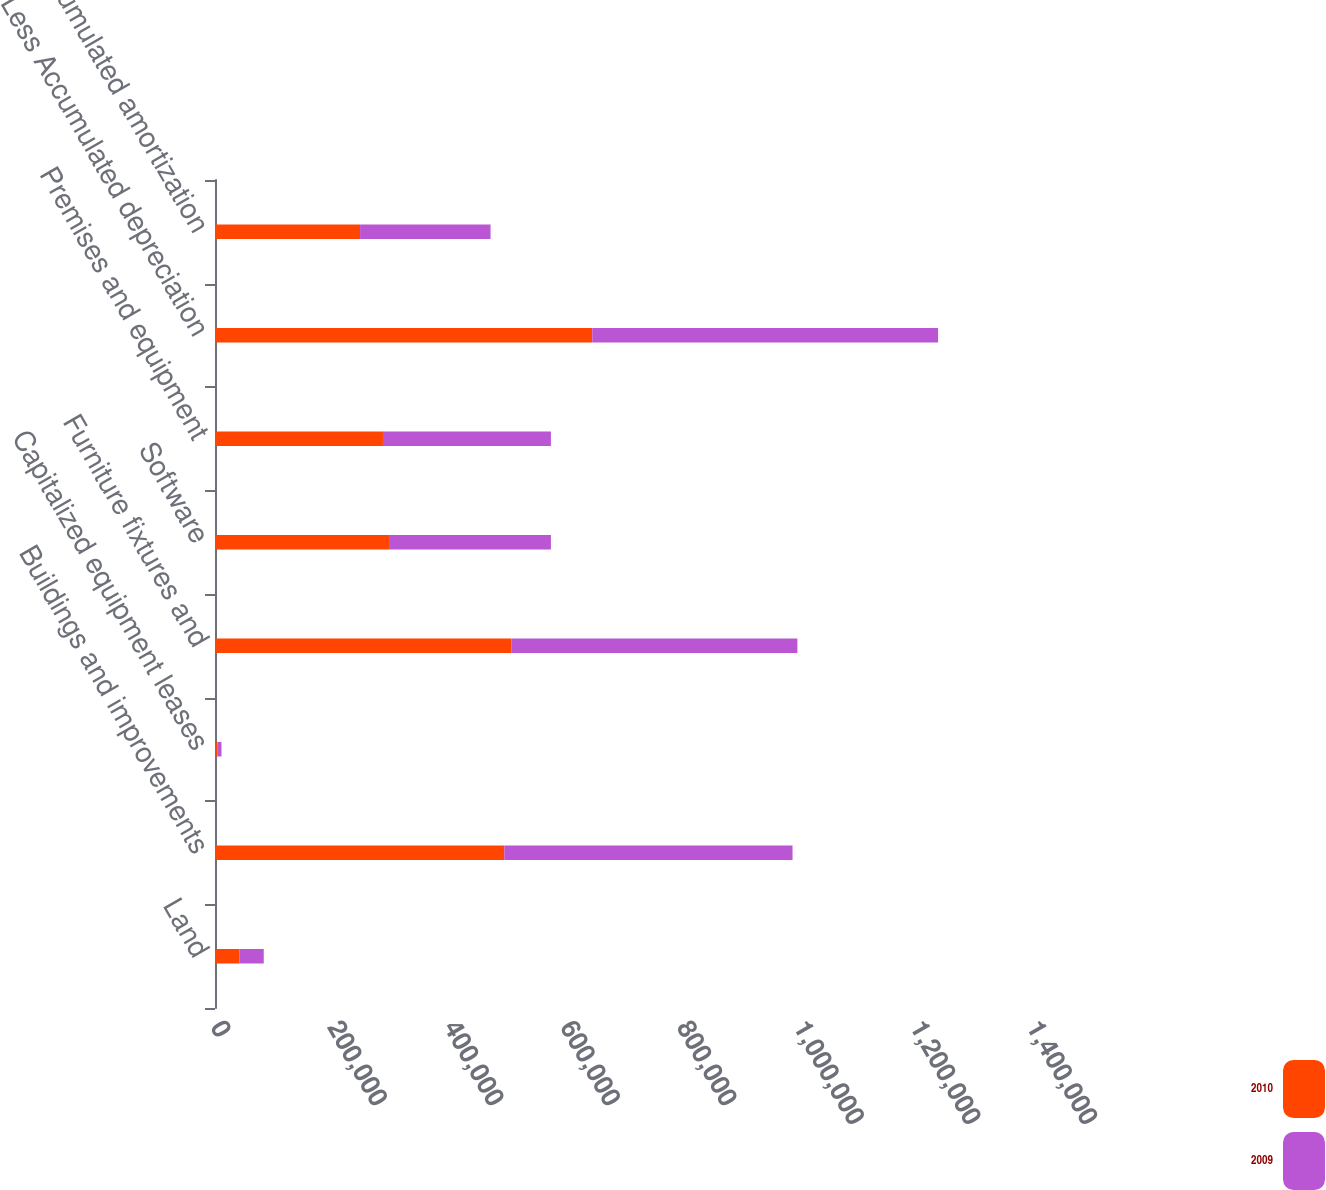Convert chart to OTSL. <chart><loc_0><loc_0><loc_500><loc_500><stacked_bar_chart><ecel><fcel>Land<fcel>Buildings and improvements<fcel>Capitalized equipment leases<fcel>Furniture fixtures and<fcel>Software<fcel>Premises and equipment<fcel>Less Accumulated depreciation<fcel>Less Accumulated amortization<nl><fcel>2010<fcel>41816<fcel>496352<fcel>3962<fcel>508599<fcel>300018<fcel>288158<fcel>647256<fcel>248877<nl><fcel>2009<fcel>41816<fcel>494511<fcel>7132<fcel>490594<fcel>276298<fcel>288158<fcel>593295<fcel>223871<nl></chart> 